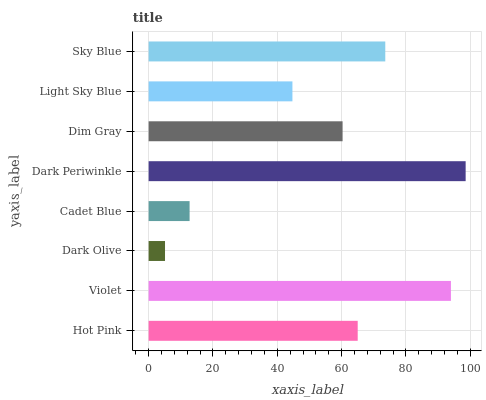Is Dark Olive the minimum?
Answer yes or no. Yes. Is Dark Periwinkle the maximum?
Answer yes or no. Yes. Is Violet the minimum?
Answer yes or no. No. Is Violet the maximum?
Answer yes or no. No. Is Violet greater than Hot Pink?
Answer yes or no. Yes. Is Hot Pink less than Violet?
Answer yes or no. Yes. Is Hot Pink greater than Violet?
Answer yes or no. No. Is Violet less than Hot Pink?
Answer yes or no. No. Is Hot Pink the high median?
Answer yes or no. Yes. Is Dim Gray the low median?
Answer yes or no. Yes. Is Violet the high median?
Answer yes or no. No. Is Dark Periwinkle the low median?
Answer yes or no. No. 